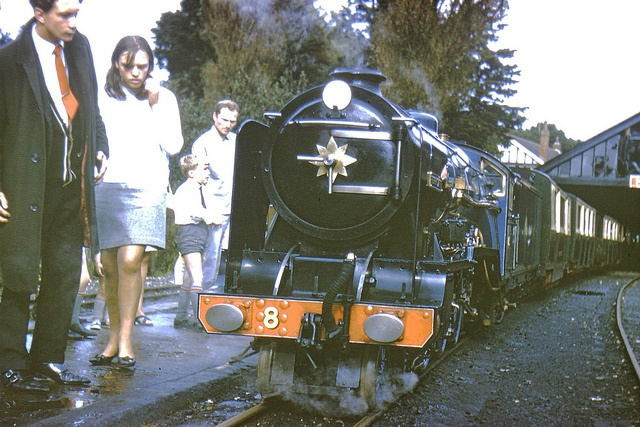Describe the objects in this image and their specific colors. I can see train in white, darkgreen, gray, and black tones, people in white, darkgreen, gray, and black tones, people in white, darkgray, gray, and tan tones, people in white, darkgray, and gray tones, and people in white, darkgray, and gray tones in this image. 